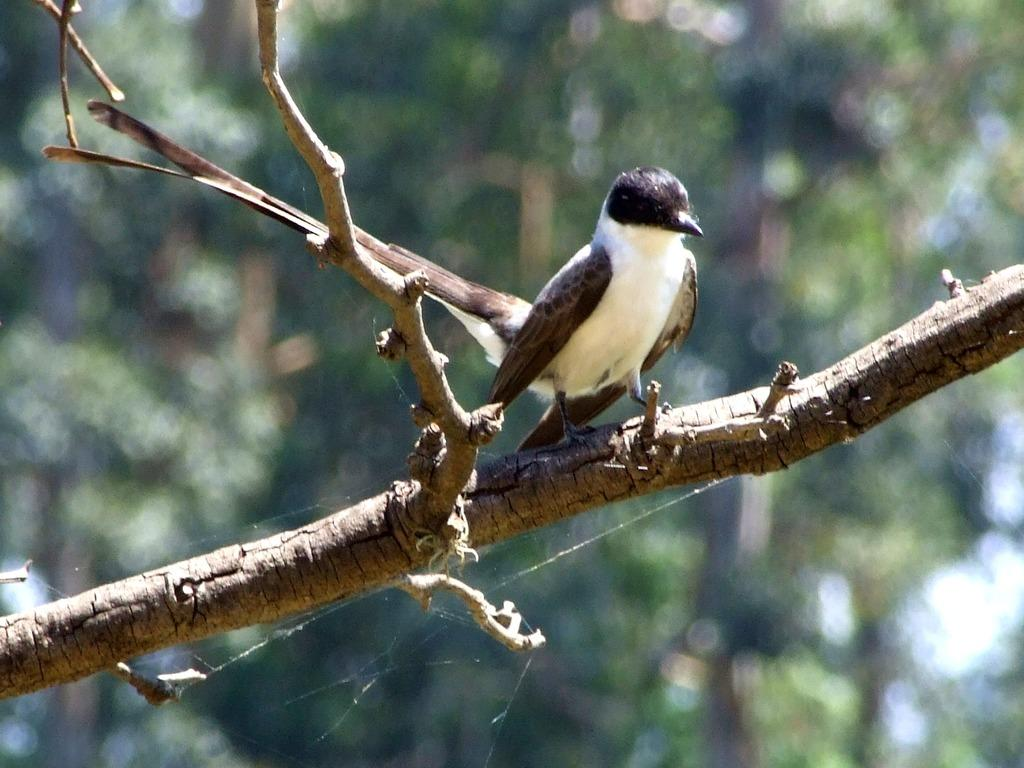What type of animal is in the image? There is a bird in the image. Where is the bird located? The bird is on a branch of a tree. Can you describe the background of the image? The background of the image is blurred. What color are the bird's eyes in the image? The image does not provide enough detail to determine the color of the bird's eyes. 